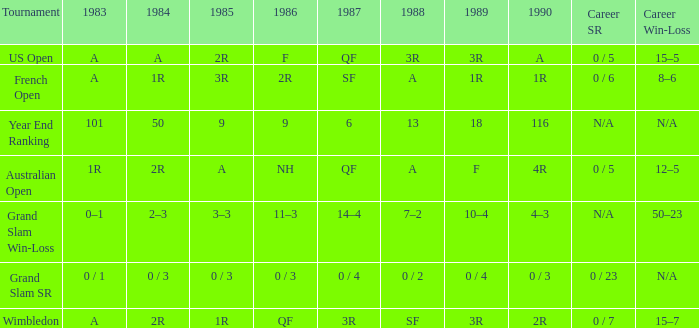Give me the full table as a dictionary. {'header': ['Tournament', '1983', '1984', '1985', '1986', '1987', '1988', '1989', '1990', 'Career SR', 'Career Win-Loss'], 'rows': [['US Open', 'A', 'A', '2R', 'F', 'QF', '3R', '3R', 'A', '0 / 5', '15–5'], ['French Open', 'A', '1R', '3R', '2R', 'SF', 'A', '1R', '1R', '0 / 6', '8–6'], ['Year End Ranking', '101', '50', '9', '9', '6', '13', '18', '116', 'N/A', 'N/A'], ['Australian Open', '1R', '2R', 'A', 'NH', 'QF', 'A', 'F', '4R', '0 / 5', '12–5'], ['Grand Slam Win-Loss', '0–1', '2–3', '3–3', '11–3', '14–4', '7–2', '10–4', '4–3', 'N/A', '50–23'], ['Grand Slam SR', '0 / 1', '0 / 3', '0 / 3', '0 / 3', '0 / 4', '0 / 2', '0 / 4', '0 / 3', '0 / 23', 'N/A'], ['Wimbledon', 'A', '2R', '1R', 'QF', '3R', 'SF', '3R', '2R', '0 / 7', '15–7']]} With a 1986 of NH and a career SR of 0 / 5 what is the results in 1985? A. 